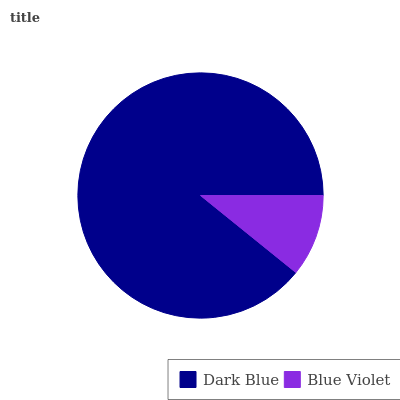Is Blue Violet the minimum?
Answer yes or no. Yes. Is Dark Blue the maximum?
Answer yes or no. Yes. Is Blue Violet the maximum?
Answer yes or no. No. Is Dark Blue greater than Blue Violet?
Answer yes or no. Yes. Is Blue Violet less than Dark Blue?
Answer yes or no. Yes. Is Blue Violet greater than Dark Blue?
Answer yes or no. No. Is Dark Blue less than Blue Violet?
Answer yes or no. No. Is Dark Blue the high median?
Answer yes or no. Yes. Is Blue Violet the low median?
Answer yes or no. Yes. Is Blue Violet the high median?
Answer yes or no. No. Is Dark Blue the low median?
Answer yes or no. No. 